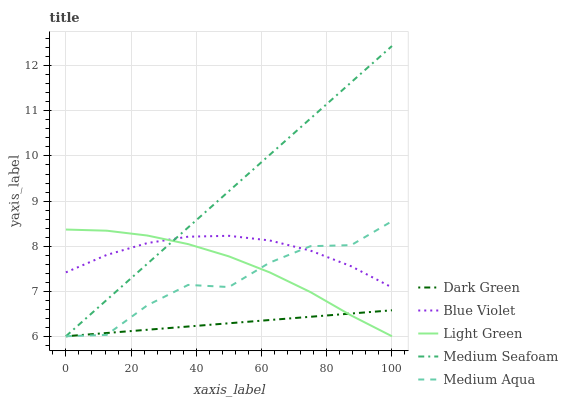Does Dark Green have the minimum area under the curve?
Answer yes or no. Yes. Does Medium Seafoam have the maximum area under the curve?
Answer yes or no. Yes. Does Medium Aqua have the minimum area under the curve?
Answer yes or no. No. Does Medium Aqua have the maximum area under the curve?
Answer yes or no. No. Is Dark Green the smoothest?
Answer yes or no. Yes. Is Medium Aqua the roughest?
Answer yes or no. Yes. Is Light Green the smoothest?
Answer yes or no. No. Is Light Green the roughest?
Answer yes or no. No. Does Medium Seafoam have the lowest value?
Answer yes or no. Yes. Does Blue Violet have the lowest value?
Answer yes or no. No. Does Medium Seafoam have the highest value?
Answer yes or no. Yes. Does Medium Aqua have the highest value?
Answer yes or no. No. Is Dark Green less than Blue Violet?
Answer yes or no. Yes. Is Blue Violet greater than Dark Green?
Answer yes or no. Yes. Does Light Green intersect Blue Violet?
Answer yes or no. Yes. Is Light Green less than Blue Violet?
Answer yes or no. No. Is Light Green greater than Blue Violet?
Answer yes or no. No. Does Dark Green intersect Blue Violet?
Answer yes or no. No. 